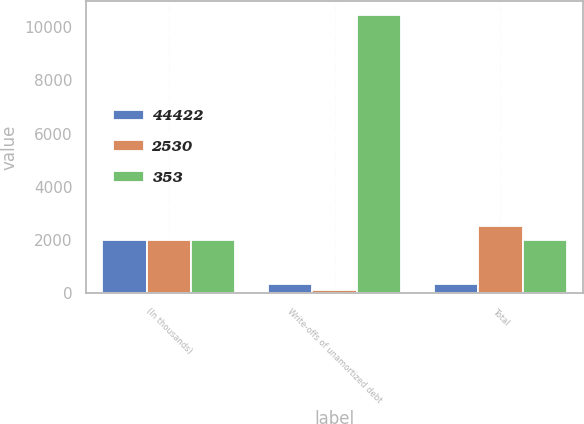Convert chart. <chart><loc_0><loc_0><loc_500><loc_500><stacked_bar_chart><ecel><fcel>(In thousands)<fcel>Write-offs of unamortized debt<fcel>Total<nl><fcel>44422<fcel>2016<fcel>353<fcel>353<nl><fcel>2530<fcel>2015<fcel>135<fcel>2530<nl><fcel>353<fcel>2014<fcel>10451<fcel>2014.5<nl></chart> 